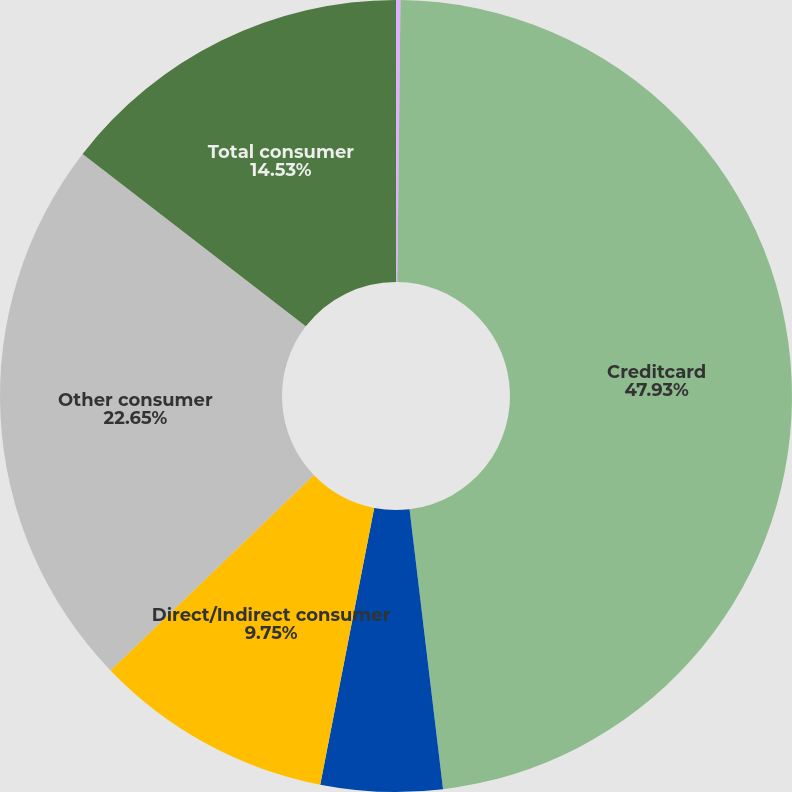Convert chart to OTSL. <chart><loc_0><loc_0><loc_500><loc_500><pie_chart><fcel>Residential mortgage<fcel>Creditcard<fcel>Homeequitylines<fcel>Direct/Indirect consumer<fcel>Other consumer<fcel>Total consumer<nl><fcel>0.18%<fcel>47.92%<fcel>4.96%<fcel>9.75%<fcel>22.65%<fcel>14.53%<nl></chart> 